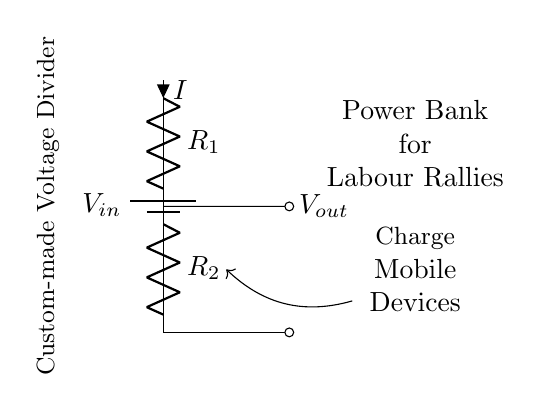What is the input voltage of this circuit? The input voltage is indicated on the battery symbol as V_in, which is the power source for the circuit.
Answer: V_in What are the two resistors in the circuit? The resistors are labeled as R_1 and R_2, and they divide the input voltage to produce a lower output voltage.
Answer: R_1 and R_2 What does V_out represent in the diagram? V_out is the output voltage, which is taken from the junction between the two resistors R_1 and R_2 and used to charge mobile devices.
Answer: V_out What is the function of this voltage divider? The voltage divider takes the input voltage and produces a lower output voltage suitable for charging mobile devices during rallies.
Answer: To charge mobile devices What can you say about the current flowing through R_1 and R_2? The current I flows through both resistors R_1 and R_2 in series, meaning it is the same through both components due to the series circuit configuration.
Answer: The same How can you adjust the output voltage? The output voltage can be adjusted by changing the values of the resistors R_1 and R_2, as different resistor values will create different voltage drops across them.
Answer: By changing resistor values 